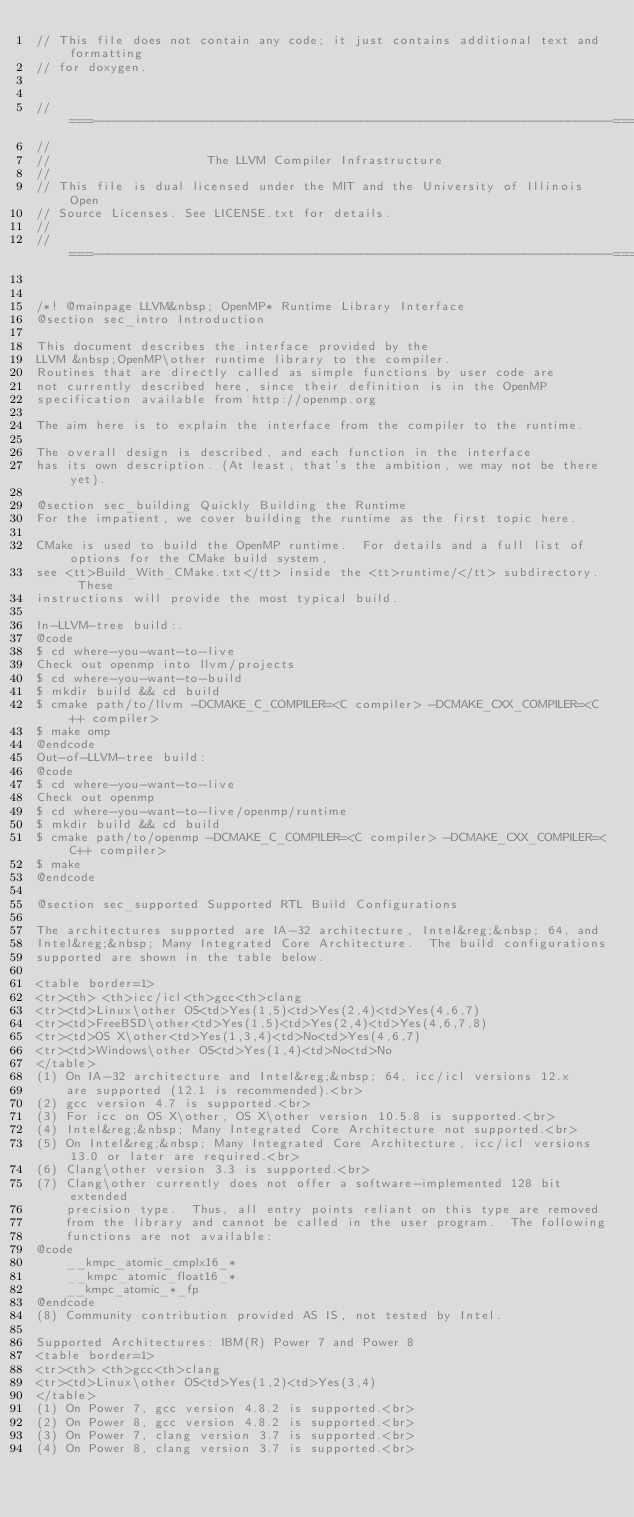<code> <loc_0><loc_0><loc_500><loc_500><_C_>// This file does not contain any code; it just contains additional text and formatting
// for doxygen.


//===----------------------------------------------------------------------===//
//
//                     The LLVM Compiler Infrastructure
//
// This file is dual licensed under the MIT and the University of Illinois Open
// Source Licenses. See LICENSE.txt for details.
//
//===----------------------------------------------------------------------===//


/*! @mainpage LLVM&nbsp; OpenMP* Runtime Library Interface
@section sec_intro Introduction

This document describes the interface provided by the
LLVM &nbsp;OpenMP\other runtime library to the compiler.
Routines that are directly called as simple functions by user code are
not currently described here, since their definition is in the OpenMP
specification available from http://openmp.org

The aim here is to explain the interface from the compiler to the runtime.

The overall design is described, and each function in the interface
has its own description. (At least, that's the ambition, we may not be there yet).

@section sec_building Quickly Building the Runtime
For the impatient, we cover building the runtime as the first topic here.

CMake is used to build the OpenMP runtime.  For details and a full list of options for the CMake build system,
see <tt>Build_With_CMake.txt</tt> inside the <tt>runtime/</tt> subdirectory.  These
instructions will provide the most typical build.

In-LLVM-tree build:.
@code
$ cd where-you-want-to-live
Check out openmp into llvm/projects
$ cd where-you-want-to-build
$ mkdir build && cd build
$ cmake path/to/llvm -DCMAKE_C_COMPILER=<C compiler> -DCMAKE_CXX_COMPILER=<C++ compiler>
$ make omp
@endcode
Out-of-LLVM-tree build:
@code
$ cd where-you-want-to-live
Check out openmp
$ cd where-you-want-to-live/openmp/runtime
$ mkdir build && cd build
$ cmake path/to/openmp -DCMAKE_C_COMPILER=<C compiler> -DCMAKE_CXX_COMPILER=<C++ compiler>
$ make
@endcode

@section sec_supported Supported RTL Build Configurations

The architectures supported are IA-32 architecture, Intel&reg;&nbsp; 64, and
Intel&reg;&nbsp; Many Integrated Core Architecture.  The build configurations
supported are shown in the table below.

<table border=1>
<tr><th> <th>icc/icl<th>gcc<th>clang
<tr><td>Linux\other OS<td>Yes(1,5)<td>Yes(2,4)<td>Yes(4,6,7)
<tr><td>FreeBSD\other<td>Yes(1,5)<td>Yes(2,4)<td>Yes(4,6,7,8)
<tr><td>OS X\other<td>Yes(1,3,4)<td>No<td>Yes(4,6,7)
<tr><td>Windows\other OS<td>Yes(1,4)<td>No<td>No
</table>
(1) On IA-32 architecture and Intel&reg;&nbsp; 64, icc/icl versions 12.x 
    are supported (12.1 is recommended).<br>
(2) gcc version 4.7 is supported.<br>
(3) For icc on OS X\other, OS X\other version 10.5.8 is supported.<br>
(4) Intel&reg;&nbsp; Many Integrated Core Architecture not supported.<br>
(5) On Intel&reg;&nbsp; Many Integrated Core Architecture, icc/icl versions 13.0 or later are required.<br>
(6) Clang\other version 3.3 is supported.<br>
(7) Clang\other currently does not offer a software-implemented 128 bit extended
    precision type.  Thus, all entry points reliant on this type are removed
    from the library and cannot be called in the user program.  The following
    functions are not available:
@code
    __kmpc_atomic_cmplx16_*
    __kmpc_atomic_float16_*
    __kmpc_atomic_*_fp
@endcode
(8) Community contribution provided AS IS, not tested by Intel.

Supported Architectures: IBM(R) Power 7 and Power 8
<table border=1>
<tr><th> <th>gcc<th>clang
<tr><td>Linux\other OS<td>Yes(1,2)<td>Yes(3,4)
</table>
(1) On Power 7, gcc version 4.8.2 is supported.<br>
(2) On Power 8, gcc version 4.8.2 is supported.<br>
(3) On Power 7, clang version 3.7 is supported.<br>
(4) On Power 8, clang version 3.7 is supported.<br>
</code> 